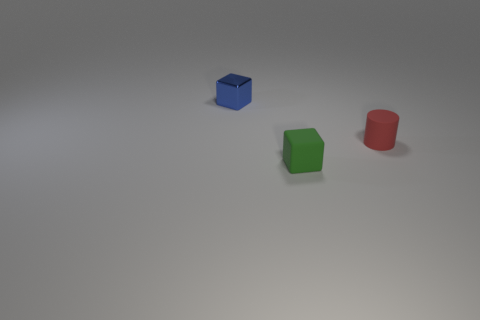Add 2 big purple spheres. How many objects exist? 5 Subtract all blocks. How many objects are left? 1 Subtract all tiny rubber cylinders. Subtract all tiny red things. How many objects are left? 1 Add 1 small cubes. How many small cubes are left? 3 Add 1 tiny gray metallic blocks. How many tiny gray metallic blocks exist? 1 Subtract 1 red cylinders. How many objects are left? 2 